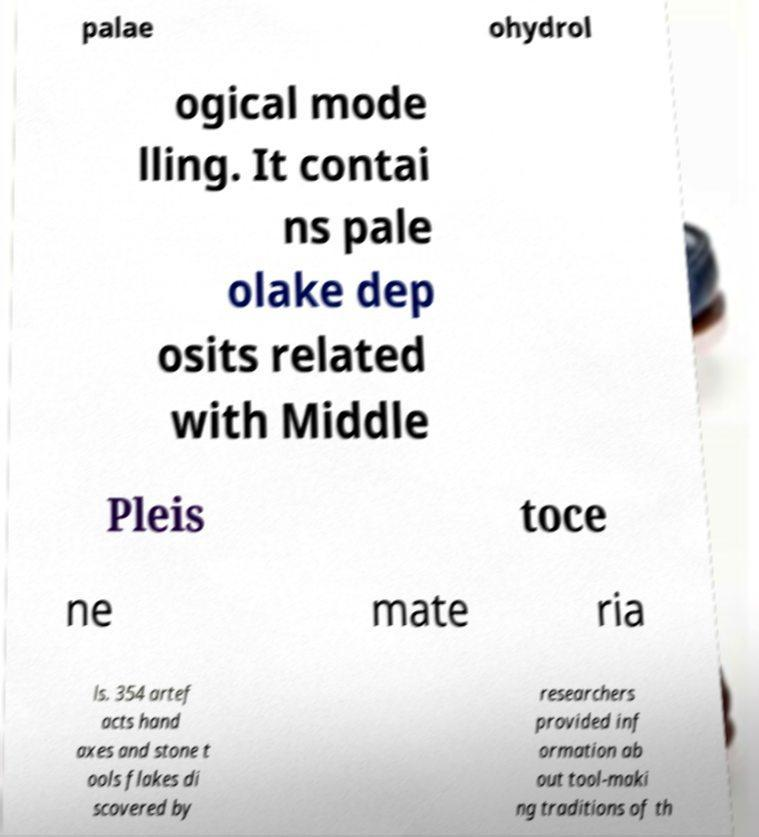Could you assist in decoding the text presented in this image and type it out clearly? palae ohydrol ogical mode lling. It contai ns pale olake dep osits related with Middle Pleis toce ne mate ria ls. 354 artef acts hand axes and stone t ools flakes di scovered by researchers provided inf ormation ab out tool-maki ng traditions of th 